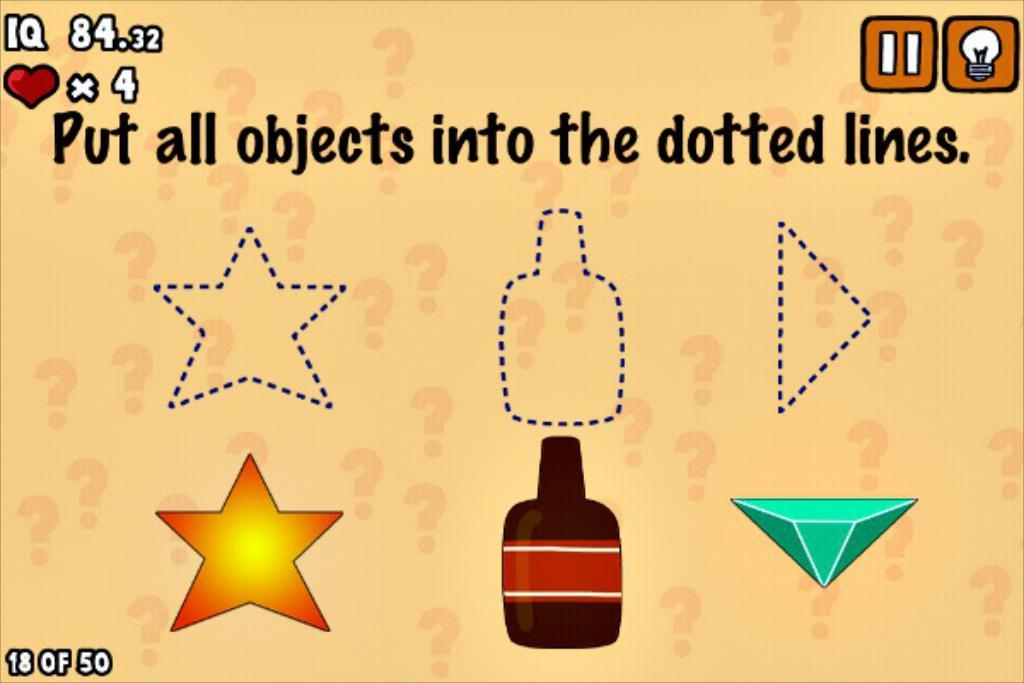Provide a one-sentence caption for the provided image. You have four lives to place three different objects into their respective dotted line cut-outs. 